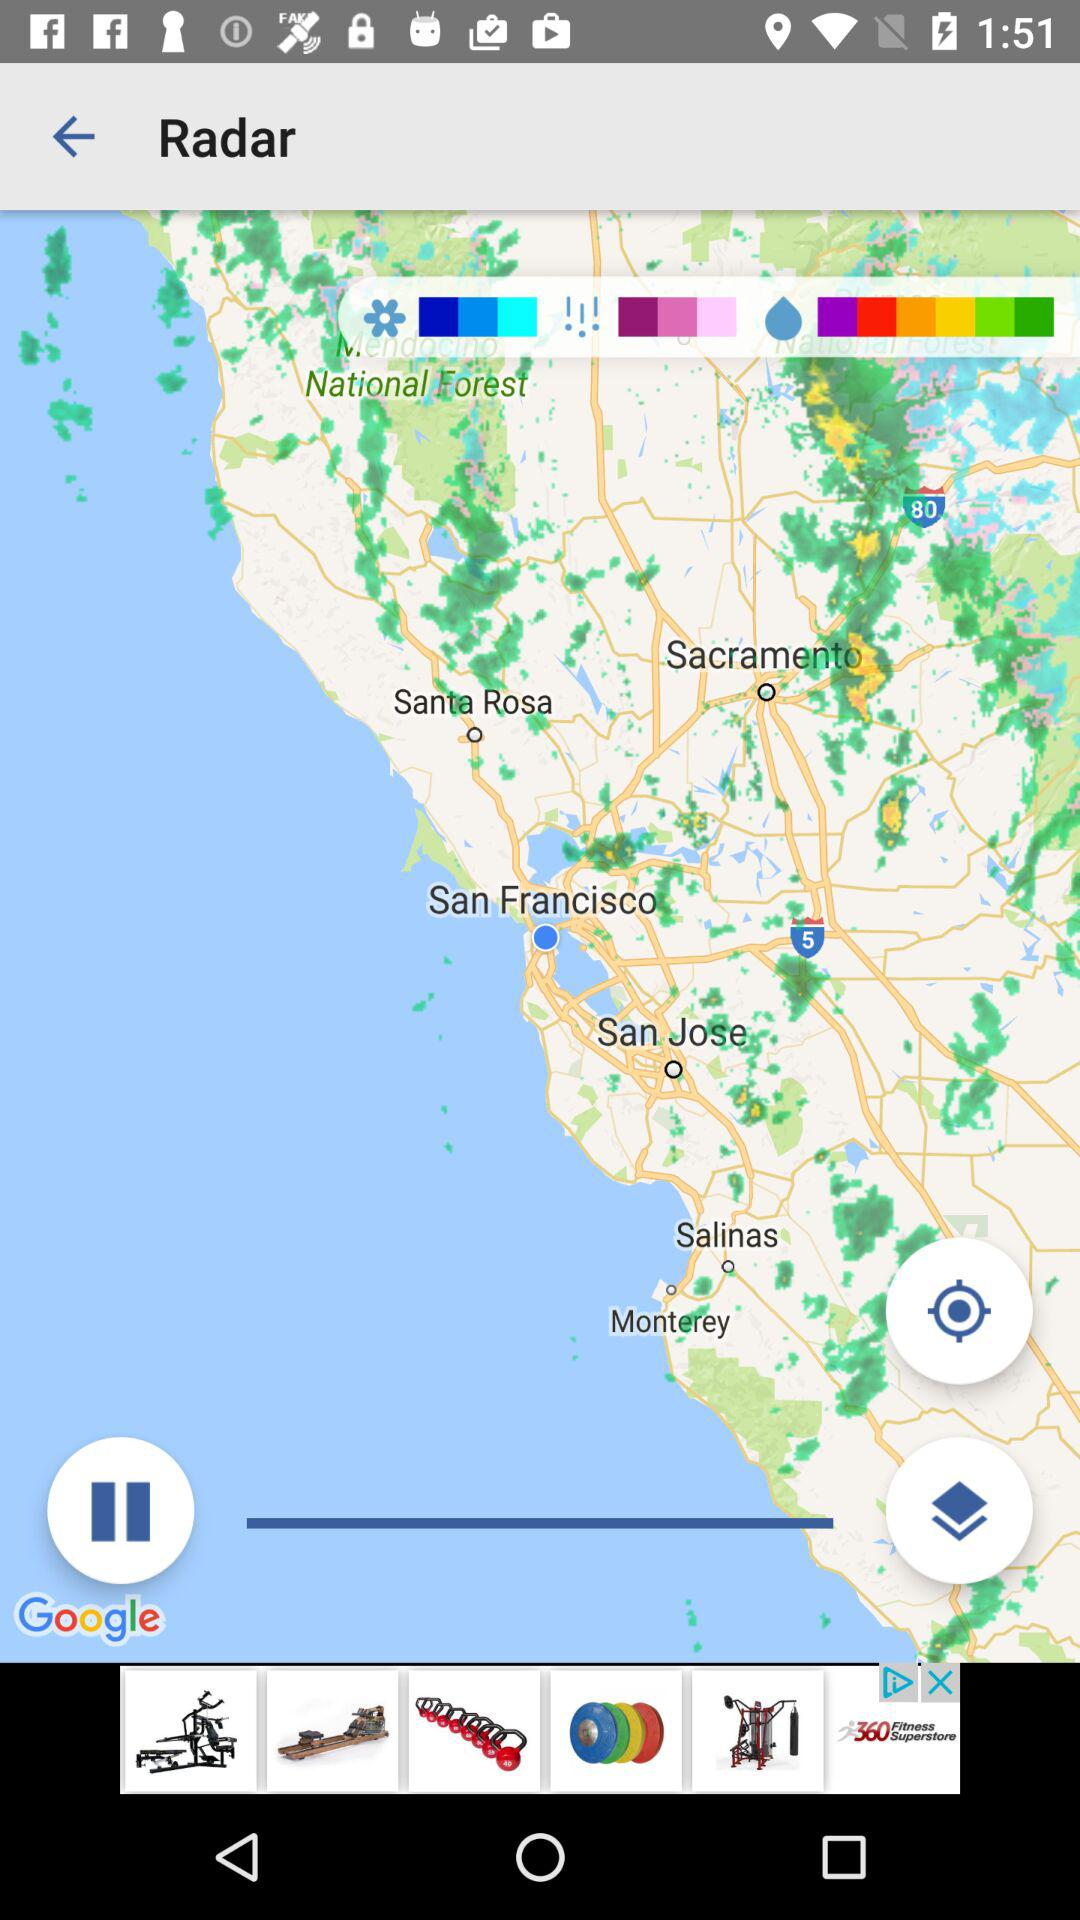What is the application name? The application name is "Google". 